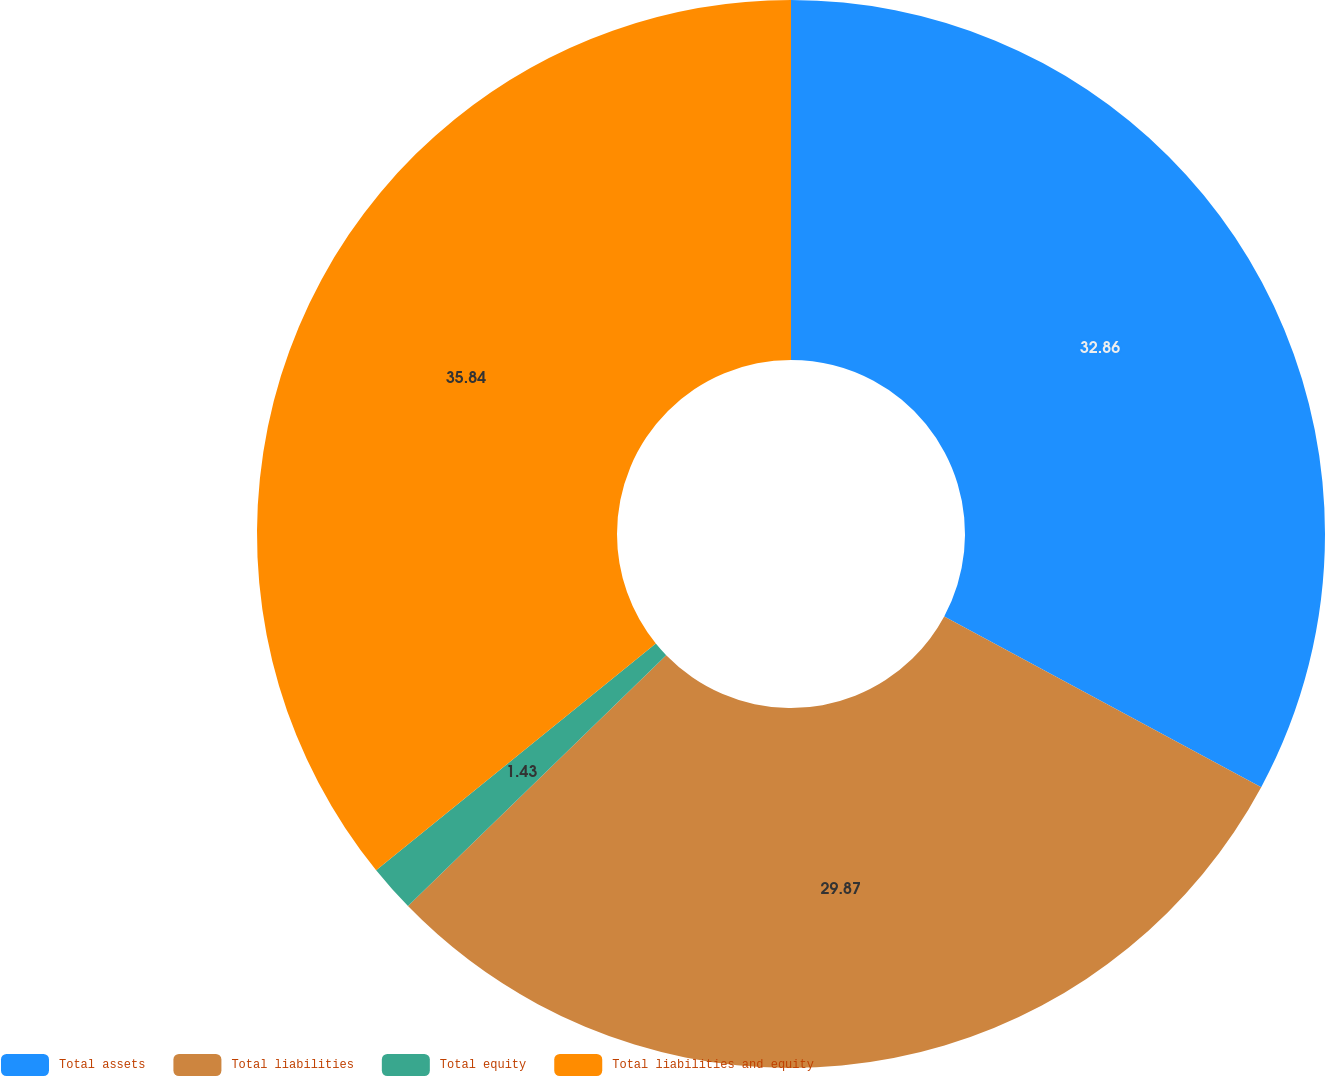<chart> <loc_0><loc_0><loc_500><loc_500><pie_chart><fcel>Total assets<fcel>Total liabilities<fcel>Total equity<fcel>Total liabilities and equity<nl><fcel>32.86%<fcel>29.87%<fcel>1.43%<fcel>35.84%<nl></chart> 